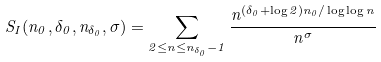Convert formula to latex. <formula><loc_0><loc_0><loc_500><loc_500>S _ { I } ( n _ { 0 } , \delta _ { 0 } , n _ { \delta _ { 0 } } , \sigma ) = \sum _ { 2 \leq n \leq n _ { \delta _ { 0 } } - 1 } \frac { n ^ { ( \delta _ { 0 } + \log 2 ) n _ { 0 } / \log \log n } } { n ^ { \sigma } }</formula> 